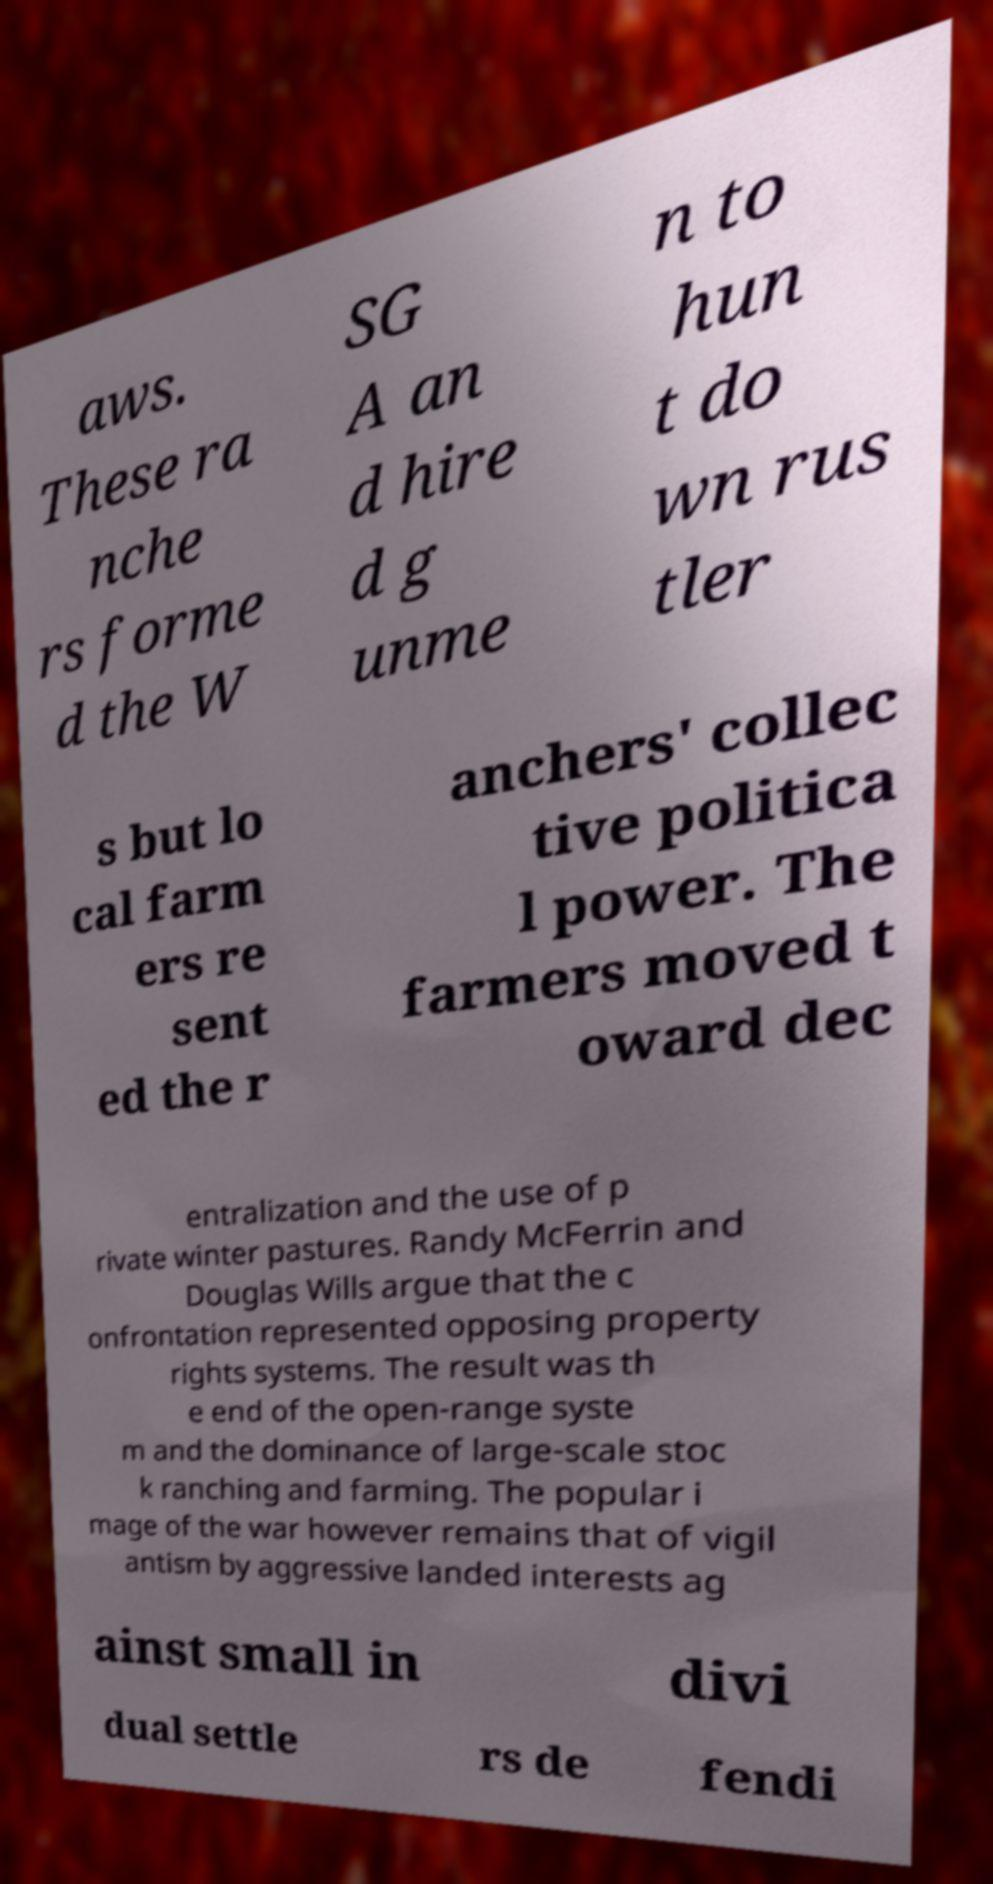What messages or text are displayed in this image? I need them in a readable, typed format. aws. These ra nche rs forme d the W SG A an d hire d g unme n to hun t do wn rus tler s but lo cal farm ers re sent ed the r anchers' collec tive politica l power. The farmers moved t oward dec entralization and the use of p rivate winter pastures. Randy McFerrin and Douglas Wills argue that the c onfrontation represented opposing property rights systems. The result was th e end of the open-range syste m and the dominance of large-scale stoc k ranching and farming. The popular i mage of the war however remains that of vigil antism by aggressive landed interests ag ainst small in divi dual settle rs de fendi 